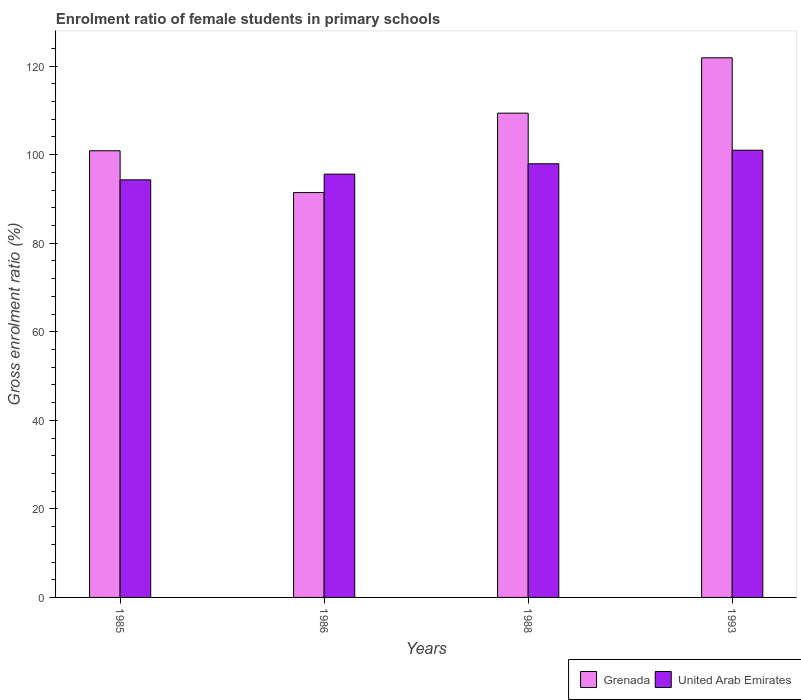How many different coloured bars are there?
Provide a succinct answer. 2. How many bars are there on the 1st tick from the left?
Offer a very short reply. 2. How many bars are there on the 4th tick from the right?
Make the answer very short. 2. What is the label of the 3rd group of bars from the left?
Offer a very short reply. 1988. In how many cases, is the number of bars for a given year not equal to the number of legend labels?
Offer a very short reply. 0. What is the enrolment ratio of female students in primary schools in Grenada in 1993?
Offer a terse response. 121.88. Across all years, what is the maximum enrolment ratio of female students in primary schools in Grenada?
Ensure brevity in your answer.  121.88. Across all years, what is the minimum enrolment ratio of female students in primary schools in Grenada?
Offer a very short reply. 91.44. In which year was the enrolment ratio of female students in primary schools in United Arab Emirates minimum?
Your answer should be very brief. 1985. What is the total enrolment ratio of female students in primary schools in United Arab Emirates in the graph?
Ensure brevity in your answer.  388.88. What is the difference between the enrolment ratio of female students in primary schools in United Arab Emirates in 1985 and that in 1988?
Provide a succinct answer. -3.63. What is the difference between the enrolment ratio of female students in primary schools in United Arab Emirates in 1986 and the enrolment ratio of female students in primary schools in Grenada in 1993?
Offer a very short reply. -26.28. What is the average enrolment ratio of female students in primary schools in United Arab Emirates per year?
Provide a short and direct response. 97.22. In the year 1993, what is the difference between the enrolment ratio of female students in primary schools in United Arab Emirates and enrolment ratio of female students in primary schools in Grenada?
Keep it short and to the point. -20.87. In how many years, is the enrolment ratio of female students in primary schools in United Arab Emirates greater than 72 %?
Ensure brevity in your answer.  4. What is the ratio of the enrolment ratio of female students in primary schools in United Arab Emirates in 1985 to that in 1986?
Offer a very short reply. 0.99. What is the difference between the highest and the second highest enrolment ratio of female students in primary schools in Grenada?
Give a very brief answer. 12.5. What is the difference between the highest and the lowest enrolment ratio of female students in primary schools in Grenada?
Offer a very short reply. 30.44. In how many years, is the enrolment ratio of female students in primary schools in United Arab Emirates greater than the average enrolment ratio of female students in primary schools in United Arab Emirates taken over all years?
Give a very brief answer. 2. Is the sum of the enrolment ratio of female students in primary schools in Grenada in 1988 and 1993 greater than the maximum enrolment ratio of female students in primary schools in United Arab Emirates across all years?
Your answer should be very brief. Yes. What does the 2nd bar from the left in 1985 represents?
Your answer should be very brief. United Arab Emirates. What does the 1st bar from the right in 1985 represents?
Provide a short and direct response. United Arab Emirates. How many years are there in the graph?
Give a very brief answer. 4. Are the values on the major ticks of Y-axis written in scientific E-notation?
Offer a very short reply. No. How many legend labels are there?
Provide a succinct answer. 2. What is the title of the graph?
Offer a terse response. Enrolment ratio of female students in primary schools. Does "Japan" appear as one of the legend labels in the graph?
Your answer should be very brief. No. What is the label or title of the Y-axis?
Give a very brief answer. Gross enrolment ratio (%). What is the Gross enrolment ratio (%) in Grenada in 1985?
Ensure brevity in your answer.  100.89. What is the Gross enrolment ratio (%) in United Arab Emirates in 1985?
Your response must be concise. 94.32. What is the Gross enrolment ratio (%) in Grenada in 1986?
Keep it short and to the point. 91.44. What is the Gross enrolment ratio (%) in United Arab Emirates in 1986?
Offer a very short reply. 95.61. What is the Gross enrolment ratio (%) of Grenada in 1988?
Provide a succinct answer. 109.38. What is the Gross enrolment ratio (%) of United Arab Emirates in 1988?
Give a very brief answer. 97.95. What is the Gross enrolment ratio (%) of Grenada in 1993?
Offer a very short reply. 121.88. What is the Gross enrolment ratio (%) of United Arab Emirates in 1993?
Your answer should be very brief. 101.01. Across all years, what is the maximum Gross enrolment ratio (%) of Grenada?
Keep it short and to the point. 121.88. Across all years, what is the maximum Gross enrolment ratio (%) of United Arab Emirates?
Keep it short and to the point. 101.01. Across all years, what is the minimum Gross enrolment ratio (%) in Grenada?
Your answer should be very brief. 91.44. Across all years, what is the minimum Gross enrolment ratio (%) of United Arab Emirates?
Give a very brief answer. 94.32. What is the total Gross enrolment ratio (%) of Grenada in the graph?
Offer a terse response. 423.59. What is the total Gross enrolment ratio (%) of United Arab Emirates in the graph?
Ensure brevity in your answer.  388.88. What is the difference between the Gross enrolment ratio (%) of Grenada in 1985 and that in 1986?
Your answer should be compact. 9.44. What is the difference between the Gross enrolment ratio (%) in United Arab Emirates in 1985 and that in 1986?
Make the answer very short. -1.29. What is the difference between the Gross enrolment ratio (%) of Grenada in 1985 and that in 1988?
Your response must be concise. -8.5. What is the difference between the Gross enrolment ratio (%) in United Arab Emirates in 1985 and that in 1988?
Give a very brief answer. -3.63. What is the difference between the Gross enrolment ratio (%) of Grenada in 1985 and that in 1993?
Your answer should be very brief. -21. What is the difference between the Gross enrolment ratio (%) of United Arab Emirates in 1985 and that in 1993?
Your answer should be very brief. -6.7. What is the difference between the Gross enrolment ratio (%) in Grenada in 1986 and that in 1988?
Provide a short and direct response. -17.94. What is the difference between the Gross enrolment ratio (%) of United Arab Emirates in 1986 and that in 1988?
Make the answer very short. -2.34. What is the difference between the Gross enrolment ratio (%) of Grenada in 1986 and that in 1993?
Provide a short and direct response. -30.44. What is the difference between the Gross enrolment ratio (%) in United Arab Emirates in 1986 and that in 1993?
Make the answer very short. -5.41. What is the difference between the Gross enrolment ratio (%) in Grenada in 1988 and that in 1993?
Your answer should be compact. -12.5. What is the difference between the Gross enrolment ratio (%) in United Arab Emirates in 1988 and that in 1993?
Keep it short and to the point. -3.06. What is the difference between the Gross enrolment ratio (%) in Grenada in 1985 and the Gross enrolment ratio (%) in United Arab Emirates in 1986?
Give a very brief answer. 5.28. What is the difference between the Gross enrolment ratio (%) of Grenada in 1985 and the Gross enrolment ratio (%) of United Arab Emirates in 1988?
Offer a very short reply. 2.94. What is the difference between the Gross enrolment ratio (%) of Grenada in 1985 and the Gross enrolment ratio (%) of United Arab Emirates in 1993?
Provide a succinct answer. -0.13. What is the difference between the Gross enrolment ratio (%) in Grenada in 1986 and the Gross enrolment ratio (%) in United Arab Emirates in 1988?
Your answer should be very brief. -6.5. What is the difference between the Gross enrolment ratio (%) in Grenada in 1986 and the Gross enrolment ratio (%) in United Arab Emirates in 1993?
Offer a terse response. -9.57. What is the difference between the Gross enrolment ratio (%) of Grenada in 1988 and the Gross enrolment ratio (%) of United Arab Emirates in 1993?
Provide a succinct answer. 8.37. What is the average Gross enrolment ratio (%) of Grenada per year?
Keep it short and to the point. 105.9. What is the average Gross enrolment ratio (%) in United Arab Emirates per year?
Your response must be concise. 97.22. In the year 1985, what is the difference between the Gross enrolment ratio (%) of Grenada and Gross enrolment ratio (%) of United Arab Emirates?
Offer a very short reply. 6.57. In the year 1986, what is the difference between the Gross enrolment ratio (%) of Grenada and Gross enrolment ratio (%) of United Arab Emirates?
Make the answer very short. -4.16. In the year 1988, what is the difference between the Gross enrolment ratio (%) in Grenada and Gross enrolment ratio (%) in United Arab Emirates?
Your answer should be compact. 11.44. In the year 1993, what is the difference between the Gross enrolment ratio (%) in Grenada and Gross enrolment ratio (%) in United Arab Emirates?
Provide a short and direct response. 20.87. What is the ratio of the Gross enrolment ratio (%) in Grenada in 1985 to that in 1986?
Provide a succinct answer. 1.1. What is the ratio of the Gross enrolment ratio (%) of United Arab Emirates in 1985 to that in 1986?
Your response must be concise. 0.99. What is the ratio of the Gross enrolment ratio (%) of Grenada in 1985 to that in 1988?
Your response must be concise. 0.92. What is the ratio of the Gross enrolment ratio (%) of United Arab Emirates in 1985 to that in 1988?
Offer a very short reply. 0.96. What is the ratio of the Gross enrolment ratio (%) of Grenada in 1985 to that in 1993?
Keep it short and to the point. 0.83. What is the ratio of the Gross enrolment ratio (%) of United Arab Emirates in 1985 to that in 1993?
Make the answer very short. 0.93. What is the ratio of the Gross enrolment ratio (%) in Grenada in 1986 to that in 1988?
Keep it short and to the point. 0.84. What is the ratio of the Gross enrolment ratio (%) of United Arab Emirates in 1986 to that in 1988?
Give a very brief answer. 0.98. What is the ratio of the Gross enrolment ratio (%) of Grenada in 1986 to that in 1993?
Ensure brevity in your answer.  0.75. What is the ratio of the Gross enrolment ratio (%) of United Arab Emirates in 1986 to that in 1993?
Provide a short and direct response. 0.95. What is the ratio of the Gross enrolment ratio (%) in Grenada in 1988 to that in 1993?
Offer a terse response. 0.9. What is the ratio of the Gross enrolment ratio (%) of United Arab Emirates in 1988 to that in 1993?
Provide a succinct answer. 0.97. What is the difference between the highest and the second highest Gross enrolment ratio (%) in Grenada?
Offer a terse response. 12.5. What is the difference between the highest and the second highest Gross enrolment ratio (%) of United Arab Emirates?
Ensure brevity in your answer.  3.06. What is the difference between the highest and the lowest Gross enrolment ratio (%) in Grenada?
Offer a very short reply. 30.44. What is the difference between the highest and the lowest Gross enrolment ratio (%) in United Arab Emirates?
Give a very brief answer. 6.7. 